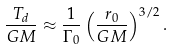<formula> <loc_0><loc_0><loc_500><loc_500>\frac { T _ { d } } { G M } \approx \frac { 1 } { \Gamma _ { 0 } } \left ( \frac { r _ { 0 } } { G M } \right ) ^ { 3 / 2 } .</formula> 